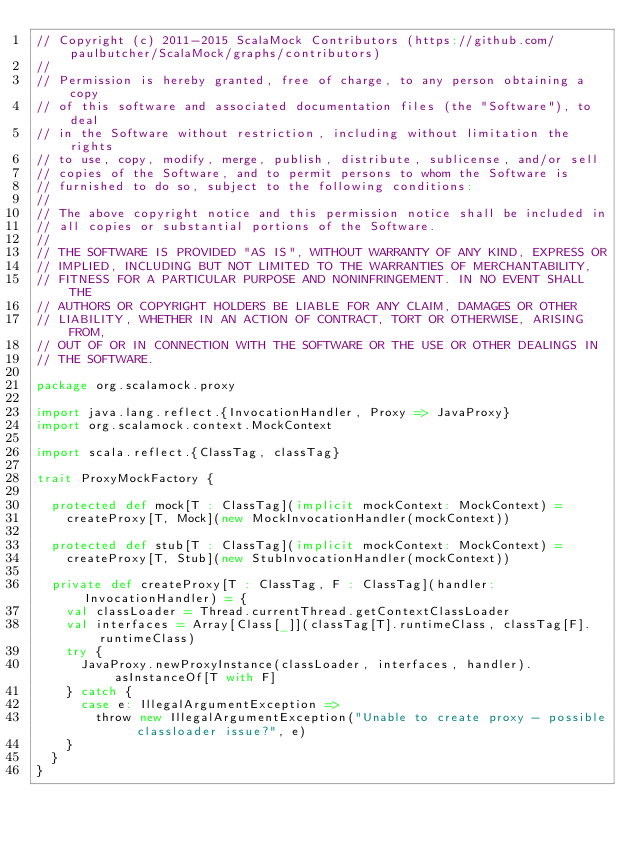Convert code to text. <code><loc_0><loc_0><loc_500><loc_500><_Scala_>// Copyright (c) 2011-2015 ScalaMock Contributors (https://github.com/paulbutcher/ScalaMock/graphs/contributors)
// 
// Permission is hereby granted, free of charge, to any person obtaining a copy
// of this software and associated documentation files (the "Software"), to deal
// in the Software without restriction, including without limitation the rights
// to use, copy, modify, merge, publish, distribute, sublicense, and/or sell
// copies of the Software, and to permit persons to whom the Software is
// furnished to do so, subject to the following conditions:
// 
// The above copyright notice and this permission notice shall be included in
// all copies or substantial portions of the Software.
// 
// THE SOFTWARE IS PROVIDED "AS IS", WITHOUT WARRANTY OF ANY KIND, EXPRESS OR
// IMPLIED, INCLUDING BUT NOT LIMITED TO THE WARRANTIES OF MERCHANTABILITY,
// FITNESS FOR A PARTICULAR PURPOSE AND NONINFRINGEMENT. IN NO EVENT SHALL THE
// AUTHORS OR COPYRIGHT HOLDERS BE LIABLE FOR ANY CLAIM, DAMAGES OR OTHER
// LIABILITY, WHETHER IN AN ACTION OF CONTRACT, TORT OR OTHERWISE, ARISING FROM,
// OUT OF OR IN CONNECTION WITH THE SOFTWARE OR THE USE OR OTHER DEALINGS IN
// THE SOFTWARE.

package org.scalamock.proxy

import java.lang.reflect.{InvocationHandler, Proxy => JavaProxy}
import org.scalamock.context.MockContext

import scala.reflect.{ClassTag, classTag}

trait ProxyMockFactory {

  protected def mock[T : ClassTag](implicit mockContext: MockContext) =
    createProxy[T, Mock](new MockInvocationHandler(mockContext))

  protected def stub[T : ClassTag](implicit mockContext: MockContext) =
    createProxy[T, Stub](new StubInvocationHandler(mockContext))

  private def createProxy[T : ClassTag, F : ClassTag](handler: InvocationHandler) = {
    val classLoader = Thread.currentThread.getContextClassLoader
    val interfaces = Array[Class[_]](classTag[T].runtimeClass, classTag[F].runtimeClass)
    try {
      JavaProxy.newProxyInstance(classLoader, interfaces, handler).asInstanceOf[T with F]
    } catch {
      case e: IllegalArgumentException => 
        throw new IllegalArgumentException("Unable to create proxy - possible classloader issue?", e)
    }
  }
}</code> 